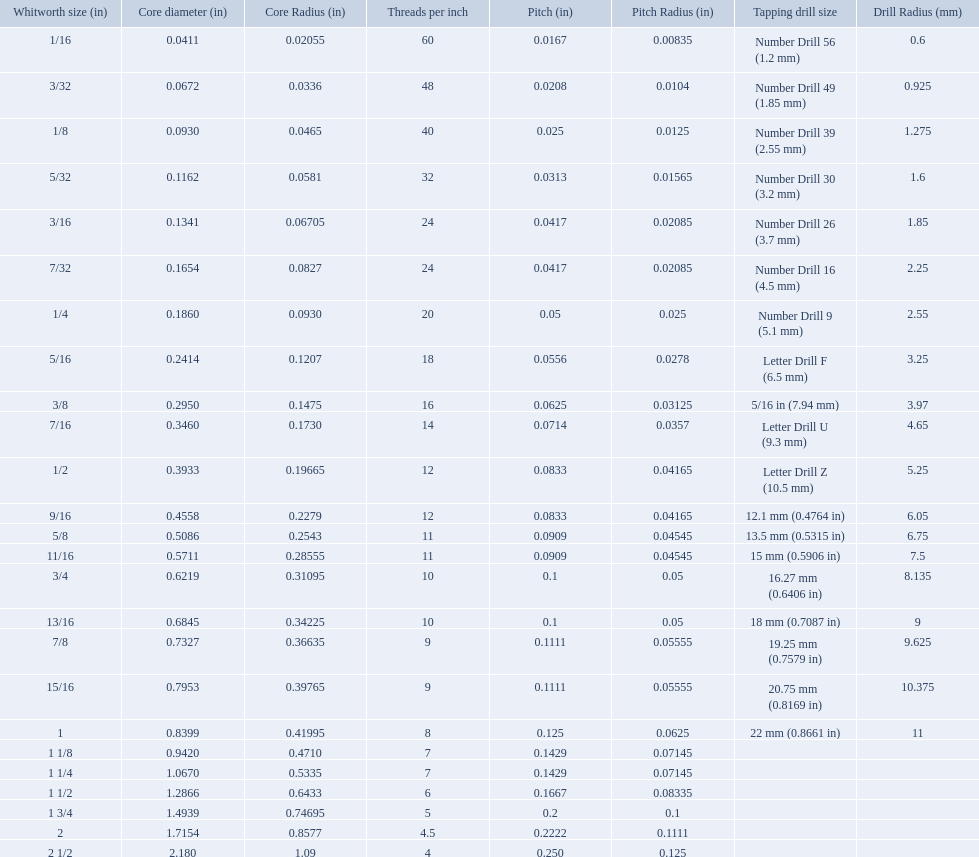What are the standard whitworth sizes in inches? 1/16, 3/32, 1/8, 5/32, 3/16, 7/32, 1/4, 5/16, 3/8, 7/16, 1/2, 9/16, 5/8, 11/16, 3/4, 13/16, 7/8, 15/16, 1, 1 1/8, 1 1/4, 1 1/2, 1 3/4, 2, 2 1/2. How many threads per inch does the 3/16 size have? 24. Which size (in inches) has the same number of threads? 7/32. What are all the whitworth sizes? 1/16, 3/32, 1/8, 5/32, 3/16, 7/32, 1/4, 5/16, 3/8, 7/16, 1/2, 9/16, 5/8, 11/16, 3/4, 13/16, 7/8, 15/16, 1, 1 1/8, 1 1/4, 1 1/2, 1 3/4, 2, 2 1/2. What are the threads per inch of these sizes? 60, 48, 40, 32, 24, 24, 20, 18, 16, 14, 12, 12, 11, 11, 10, 10, 9, 9, 8, 7, 7, 6, 5, 4.5, 4. Of these, which are 5? 5. What whitworth size has this threads per inch? 1 3/4. What are all of the whitworth sizes in the british standard whitworth? 1/16, 3/32, 1/8, 5/32, 3/16, 7/32, 1/4, 5/16, 3/8, 7/16, 1/2, 9/16, 5/8, 11/16, 3/4, 13/16, 7/8, 15/16, 1, 1 1/8, 1 1/4, 1 1/2, 1 3/4, 2, 2 1/2. Which of these sizes uses a tapping drill size of 26? 3/16. What was the core diameter of a number drill 26 0.1341. What is this measurement in whitworth size? 3/16. 